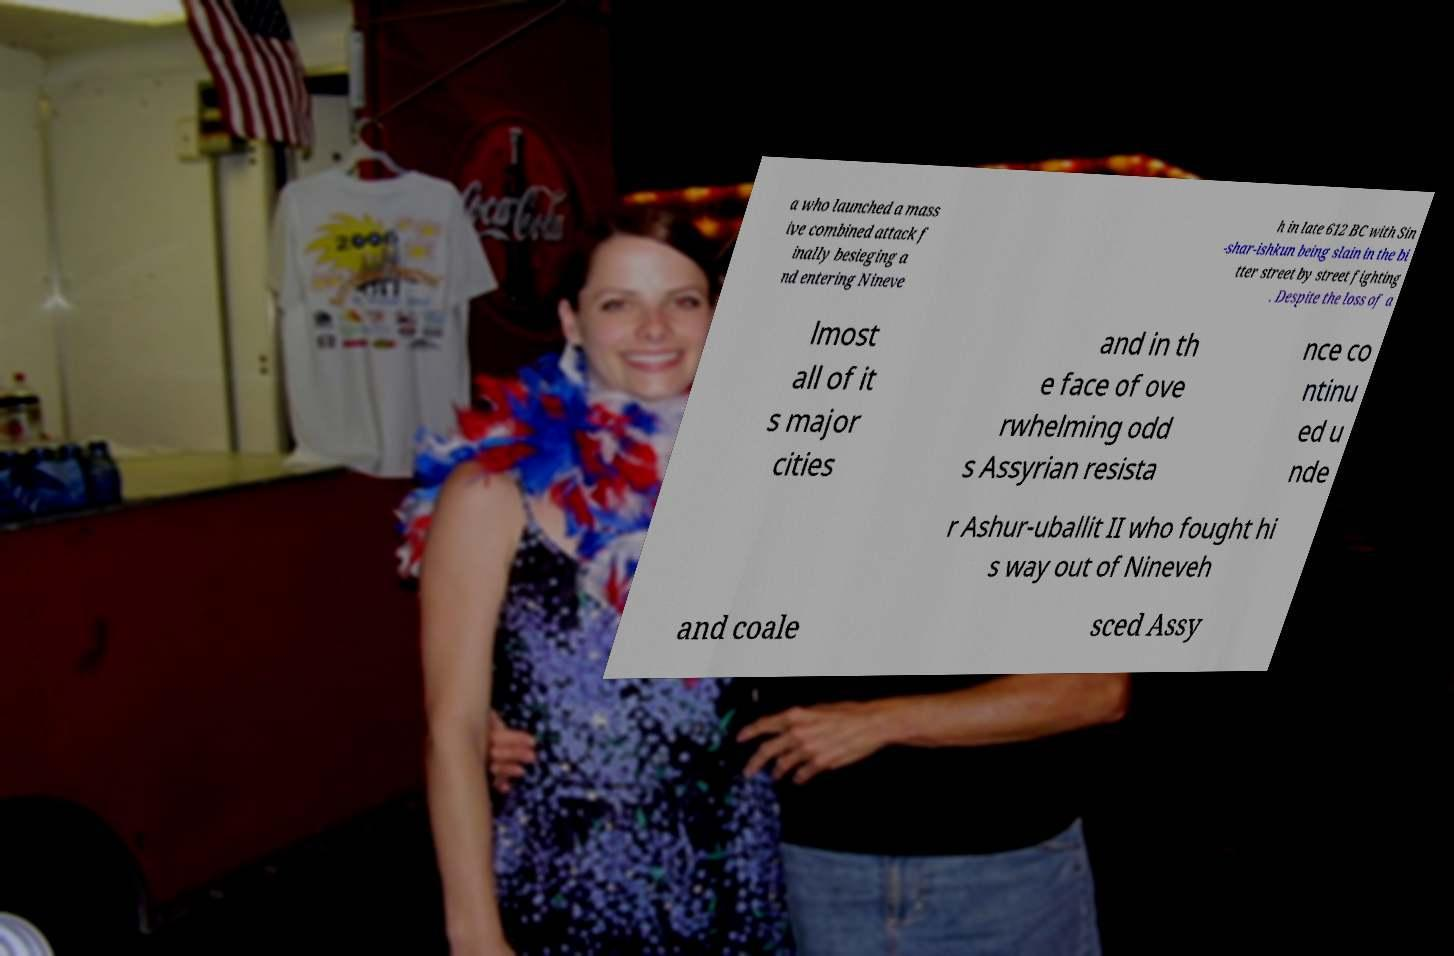Can you read and provide the text displayed in the image?This photo seems to have some interesting text. Can you extract and type it out for me? a who launched a mass ive combined attack f inally besieging a nd entering Nineve h in late 612 BC with Sin -shar-ishkun being slain in the bi tter street by street fighting . Despite the loss of a lmost all of it s major cities and in th e face of ove rwhelming odd s Assyrian resista nce co ntinu ed u nde r Ashur-uballit II who fought hi s way out of Nineveh and coale sced Assy 